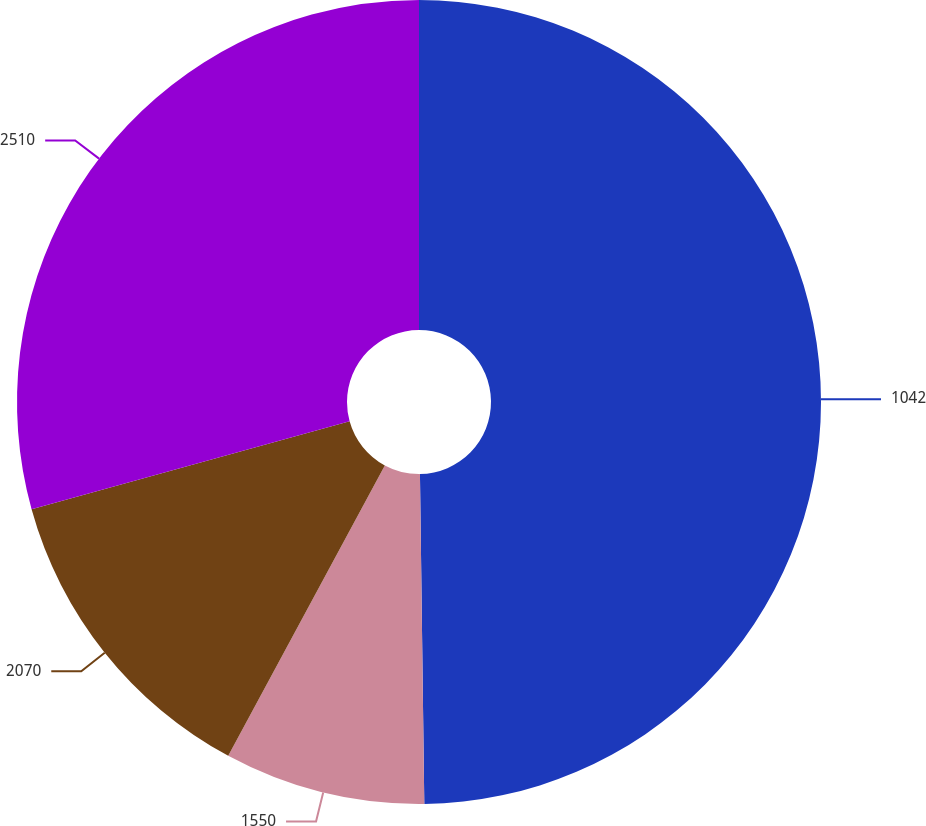Convert chart to OTSL. <chart><loc_0><loc_0><loc_500><loc_500><pie_chart><fcel>1042<fcel>1550<fcel>2070<fcel>2510<nl><fcel>49.79%<fcel>8.08%<fcel>12.83%<fcel>29.3%<nl></chart> 